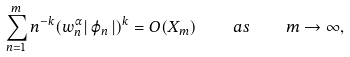Convert formula to latex. <formula><loc_0><loc_0><loc_500><loc_500>\sum _ { n = 1 } ^ { m } n ^ { - k } ( w _ { n } ^ { \alpha } | \, \varphi _ { n } \, | ) ^ { k } = O ( X _ { m } ) \quad a s \quad m \rightarrow \infty ,</formula> 